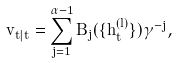<formula> <loc_0><loc_0><loc_500><loc_500>\tilde { v } _ { t | t } = \sum _ { j = 1 } ^ { \alpha - 1 } { B _ { j } ( \{ \hat { h } _ { t } ^ { ( l ) } \} ) \gamma ^ { - j } } ,</formula> 